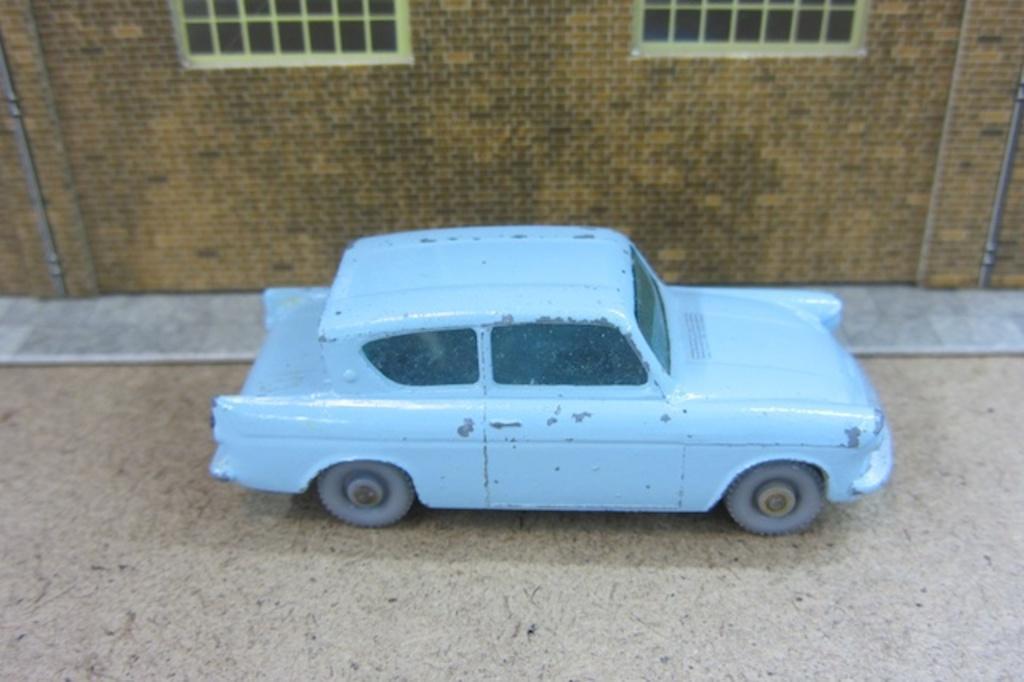Can you describe this image briefly? In the middle of the image there is a toy car on the surface. In the background there is a toy house with a wall and windows. 